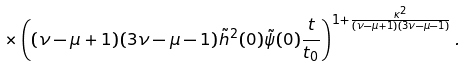Convert formula to latex. <formula><loc_0><loc_0><loc_500><loc_500>\times \left ( ( \nu - \mu + 1 ) ( 3 \nu - \mu - 1 ) \tilde { h } ^ { 2 } ( 0 ) \tilde { \psi } ( 0 ) \frac { t } { t _ { 0 } } \right ) ^ { 1 + \frac { \kappa ^ { 2 } } { ( \nu - \mu + 1 ) ( 3 \nu - \mu - 1 ) } } .</formula> 